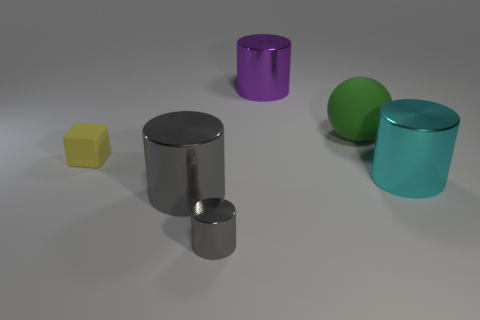Subtract all cyan cubes. How many gray cylinders are left? 2 Subtract all purple cylinders. How many cylinders are left? 3 Subtract all large gray shiny cylinders. How many cylinders are left? 3 Subtract 2 cylinders. How many cylinders are left? 2 Add 3 yellow rubber cylinders. How many objects exist? 9 Subtract all cylinders. How many objects are left? 2 Subtract all big red metal cubes. Subtract all large gray things. How many objects are left? 5 Add 2 small shiny objects. How many small shiny objects are left? 3 Add 2 tiny gray shiny cylinders. How many tiny gray shiny cylinders exist? 3 Subtract 1 yellow cubes. How many objects are left? 5 